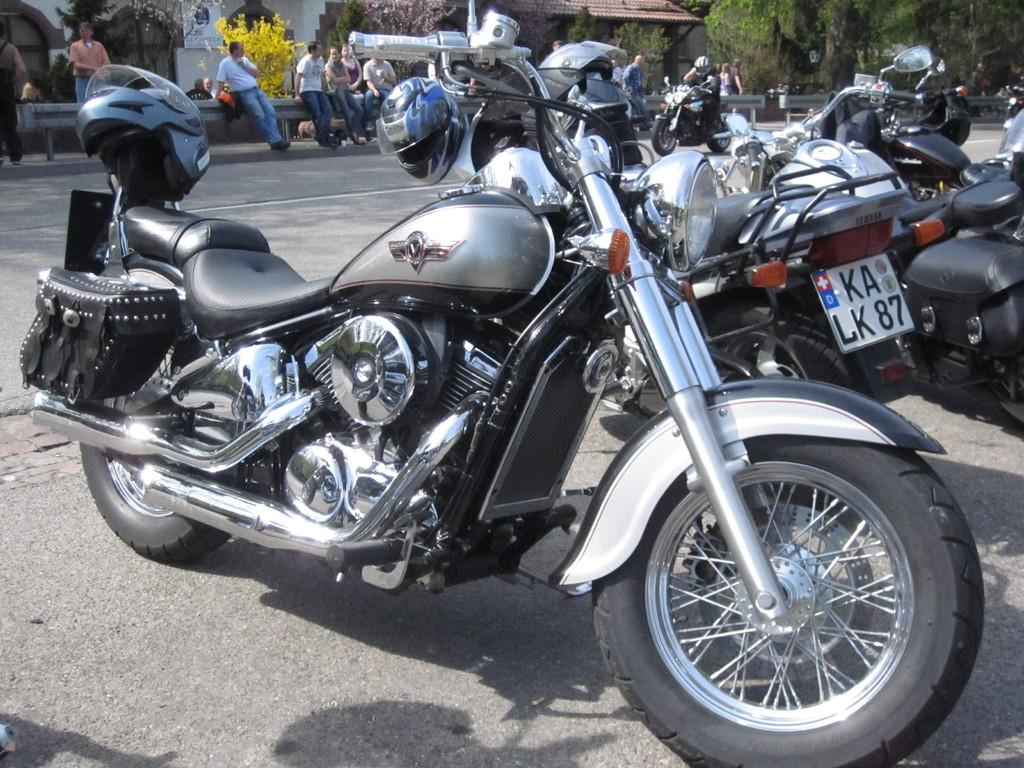What is happening in the center of the image? There are vehicles on the road in the center of the image. What can be seen in the background of the image? There are people, at least one building, and trees present in the background of the image. Can you tell me the story of the frog that is sitting on the building in the image? There is no frog present in the image, so there is no story to tell about it. 